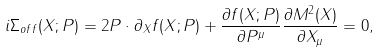<formula> <loc_0><loc_0><loc_500><loc_500>i \Sigma _ { o f f } ( X ; P ) = 2 P \cdot \partial _ { X } f ( X ; P ) + \frac { \partial f ( X ; P ) } { \partial P ^ { \mu } } \frac { \partial M ^ { 2 } ( X ) } { \partial X _ { \mu } } = 0 ,</formula> 